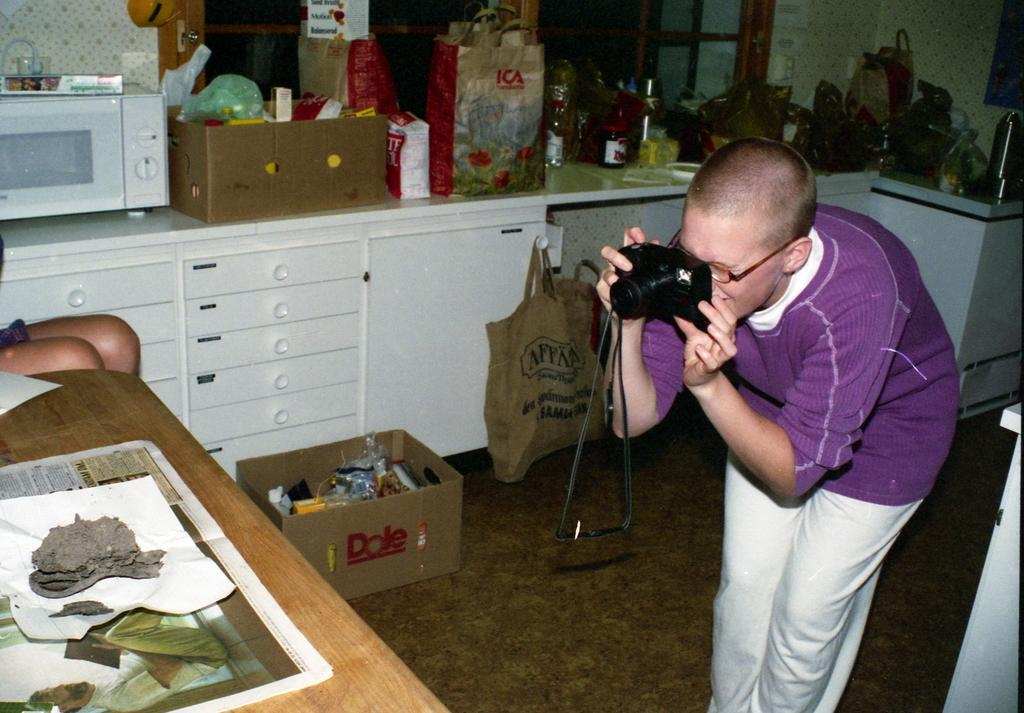<image>
Create a compact narrative representing the image presented. A person is taking a photo in their kitchen near a Dole cardboard box. 